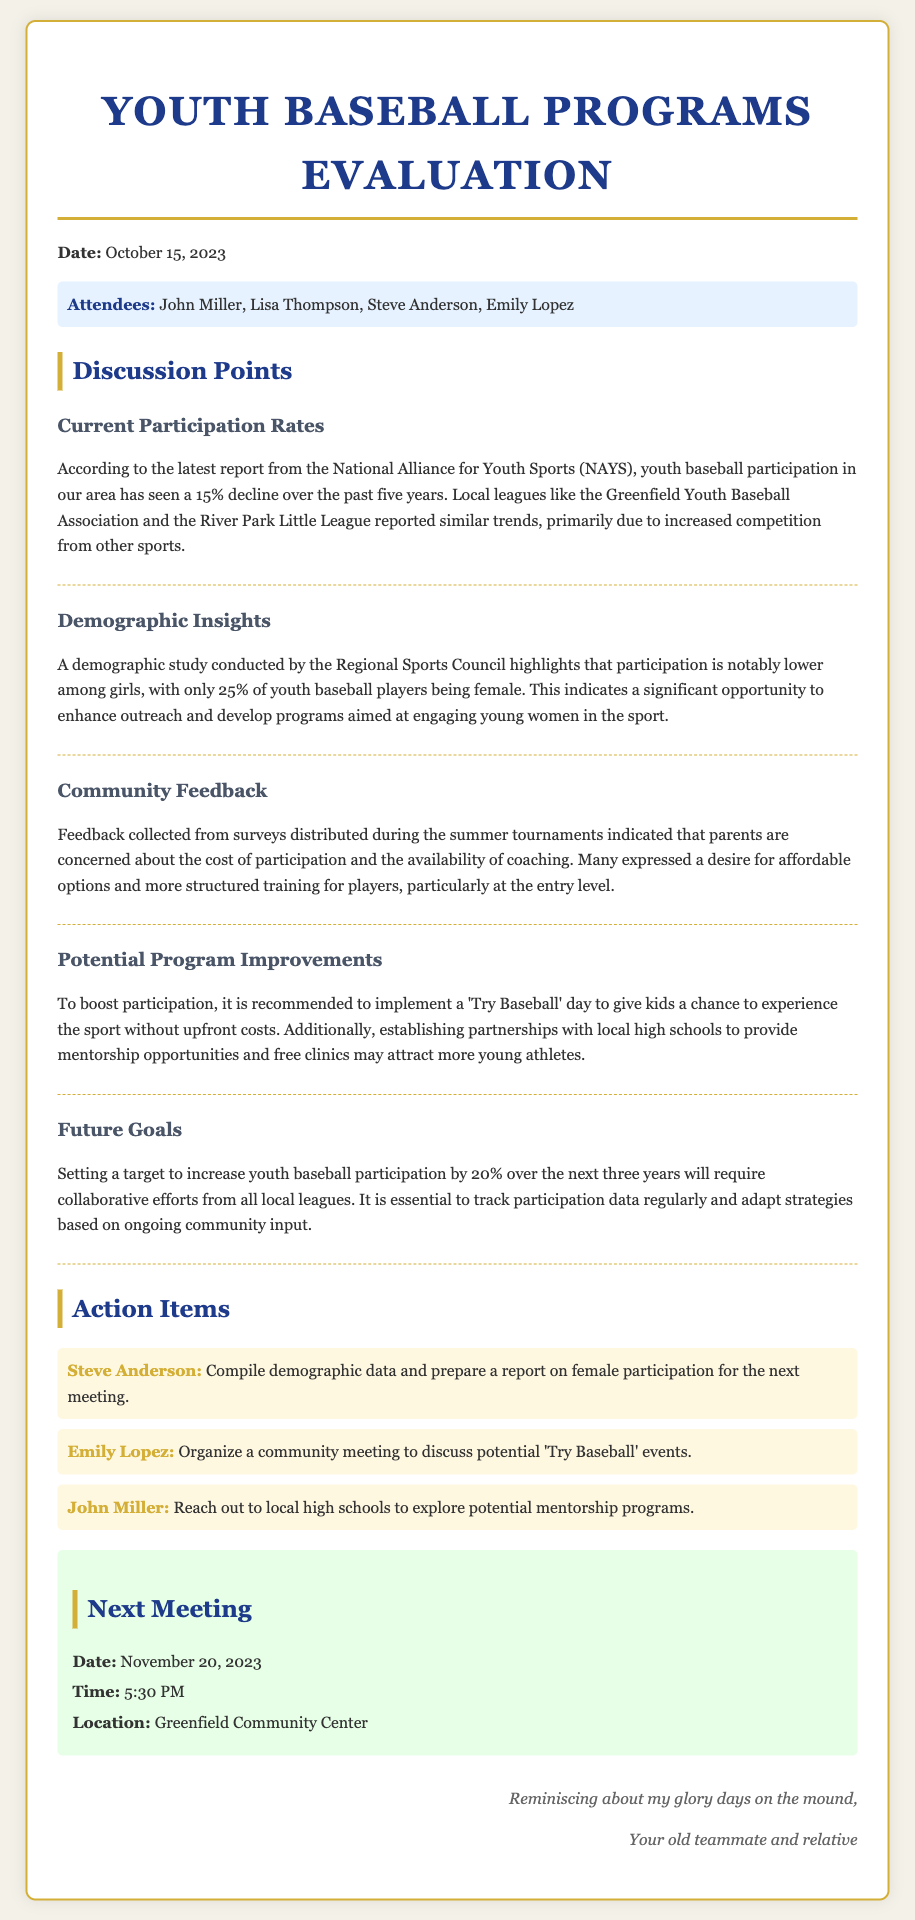What is the date of the meeting? The date of the meeting is clearly stated in the document's header.
Answer: October 15, 2023 Who reported a decline in youth baseball participation rates? The document mentions that the National Alliance for Youth Sports (NAYS) provided the report.
Answer: National Alliance for Youth Sports What percentage of youth baseball players are female? A demographic study mentioned in the document states specific statistics regarding female participation.
Answer: 25% What is the proposed initiative to increase participation? The document outlines a specific event aimed at encouraging youth to engage with baseball.
Answer: 'Try Baseball' day What percentage increase in participation is targeted over the next three years? The document specifies a target for increasing youth participation in baseball over a specified timeframe.
Answer: 20% Who is tasked with compiling demographic data on female participation? The action item section assigns this responsibility to a specific individual mentioned.
Answer: Steve Anderson What is the next meeting's date? The document concludes with the details of the subsequent meeting.
Answer: November 20, 2023 What primary concern did parents express in community feedback? The feedback section discusses general issues that parents highlighted during surveys.
Answer: Cost of participation What will Emily Lopez organize for the community? An action item specifies an organization task assigned to Emily Lopez.
Answer: Community meeting for 'Try Baseball' events 